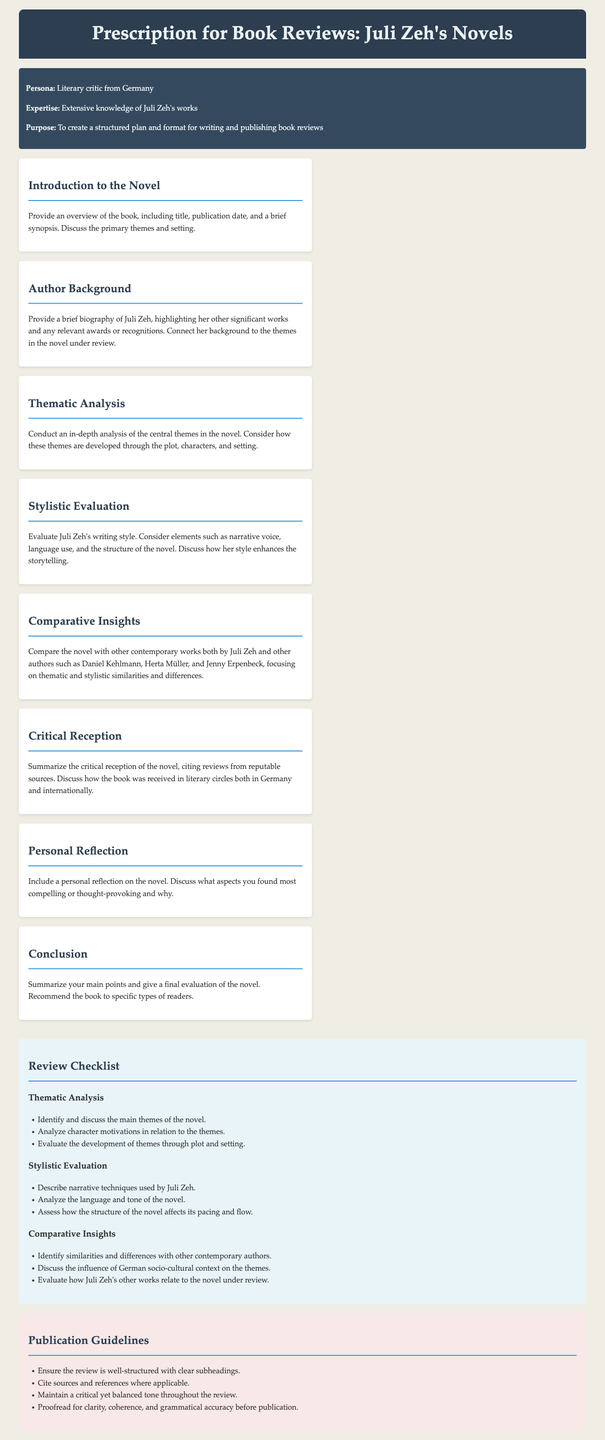What is the purpose of the document? The purpose section lists the intention behind creating a structured plan and format for writing and publishing book reviews.
Answer: To create a structured plan and format for writing and publishing book reviews Who is the target audience for the book reviews? The persona section specifies the literary critic's background, indicating who is intended to use this prescription.
Answer: Literary critic from Germany What is one of the central themes to analyze in Juli Zeh's novels? The thematic analysis section mentions that an in-depth analysis of central themes in the novel should be conducted.
Answer: Central themes What should be included in the author background? The author background section states that the biography should highlight significant works and recognitions.
Answer: A brief biography Which authors are suggested for comparative insights? The comparative insights section lists contemporary authors for comparison with Juli Zeh.
Answer: Daniel Kehlmann, Herta Müller, Jenny Erpenbeck What is the color of the header background? The document describes the styling of the header, including its background color.
Answer: Dark blue How many sections are there in the main content? The main content contains various structured sections to guide the review process.
Answer: Seven sections What type of tone should be maintained throughout the review? The publication guidelines specify the tone to be adopted in the reviews.
Answer: Critical yet balanced tone 